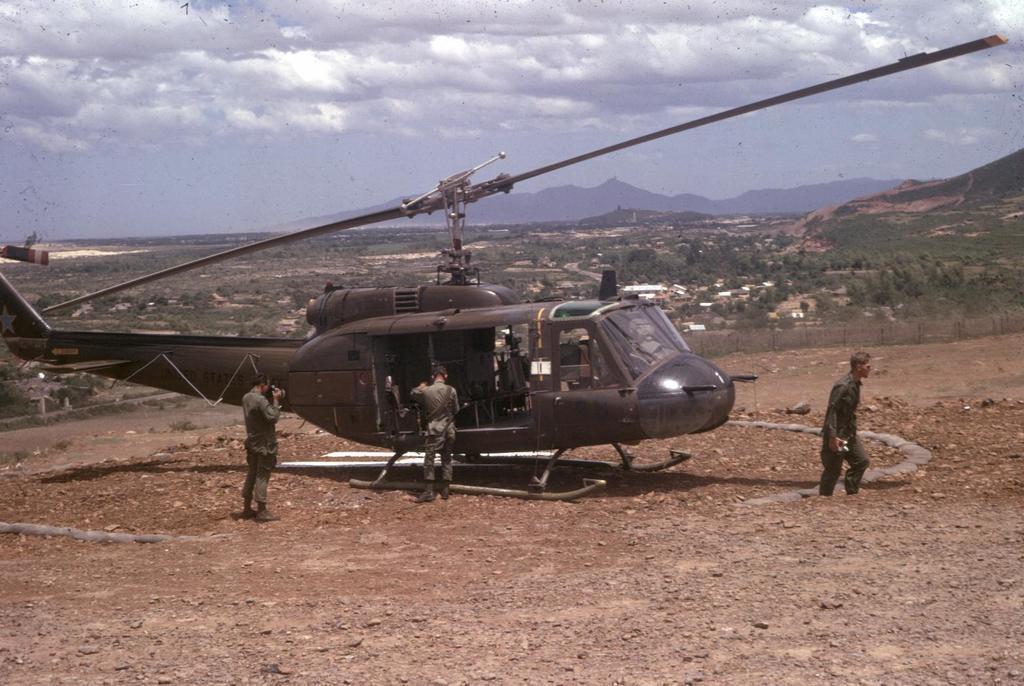How would you summarize this image in a sentence or two? In this image there is an airplane, in front of the airplane there are three people standing on the surface, in them one is walking. In the background there are trees, few buildings, mountains and the sky. 